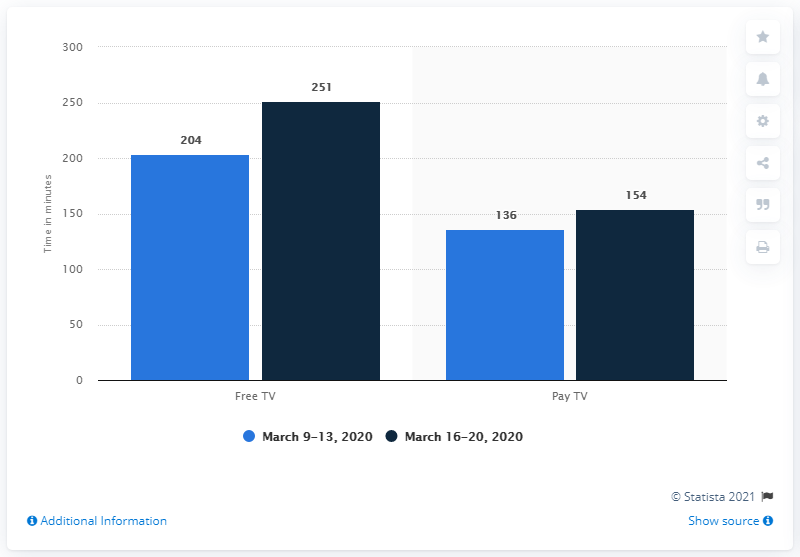Outline some significant characteristics in this image. The average value of Free TV is 227.5. The greatest value on this graph is 251. 